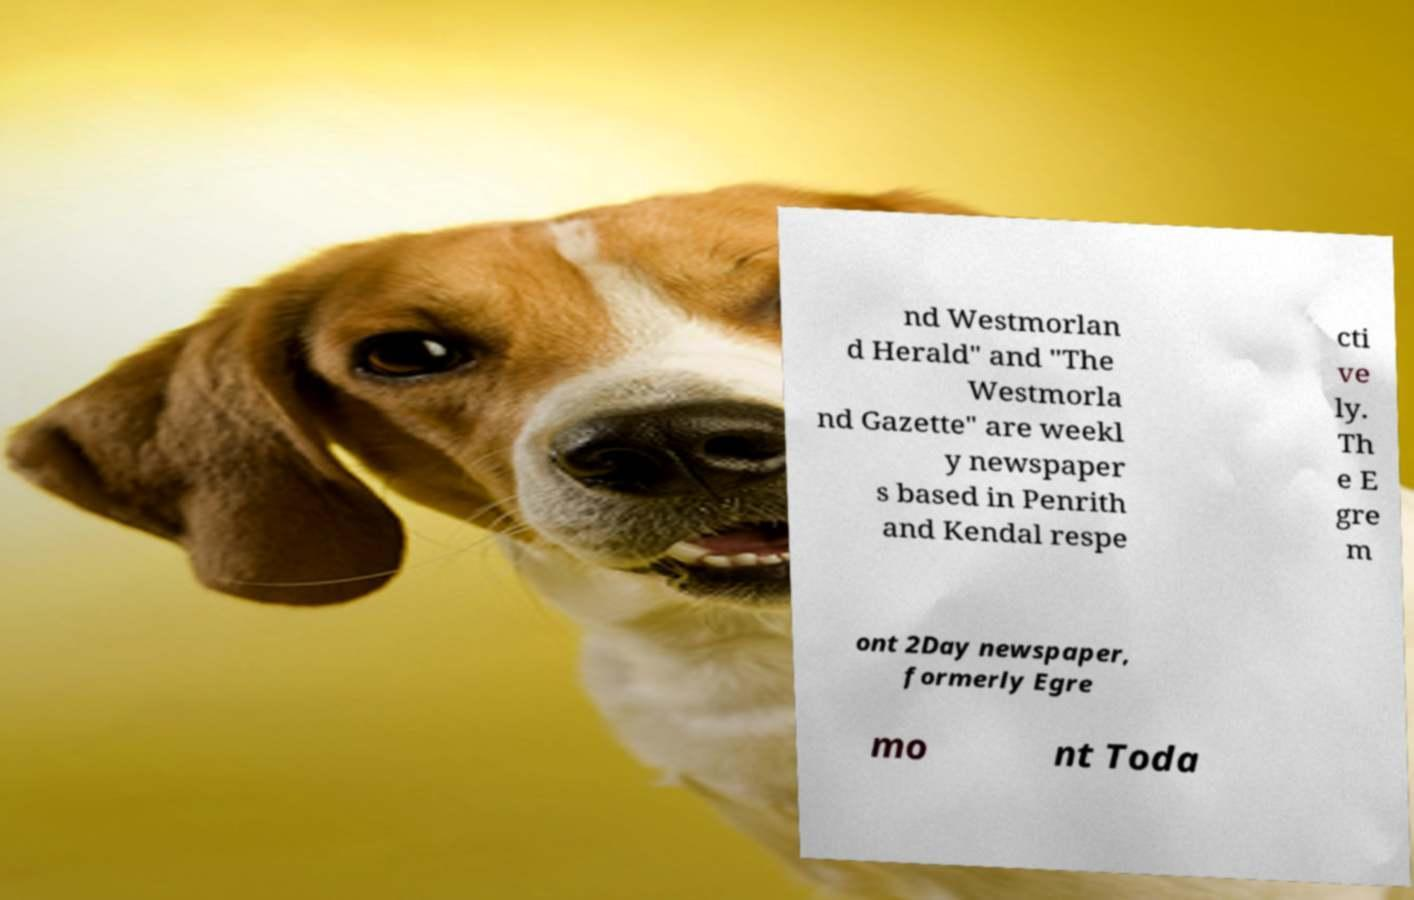Please read and relay the text visible in this image. What does it say? nd Westmorlan d Herald" and "The Westmorla nd Gazette" are weekl y newspaper s based in Penrith and Kendal respe cti ve ly. Th e E gre m ont 2Day newspaper, formerly Egre mo nt Toda 